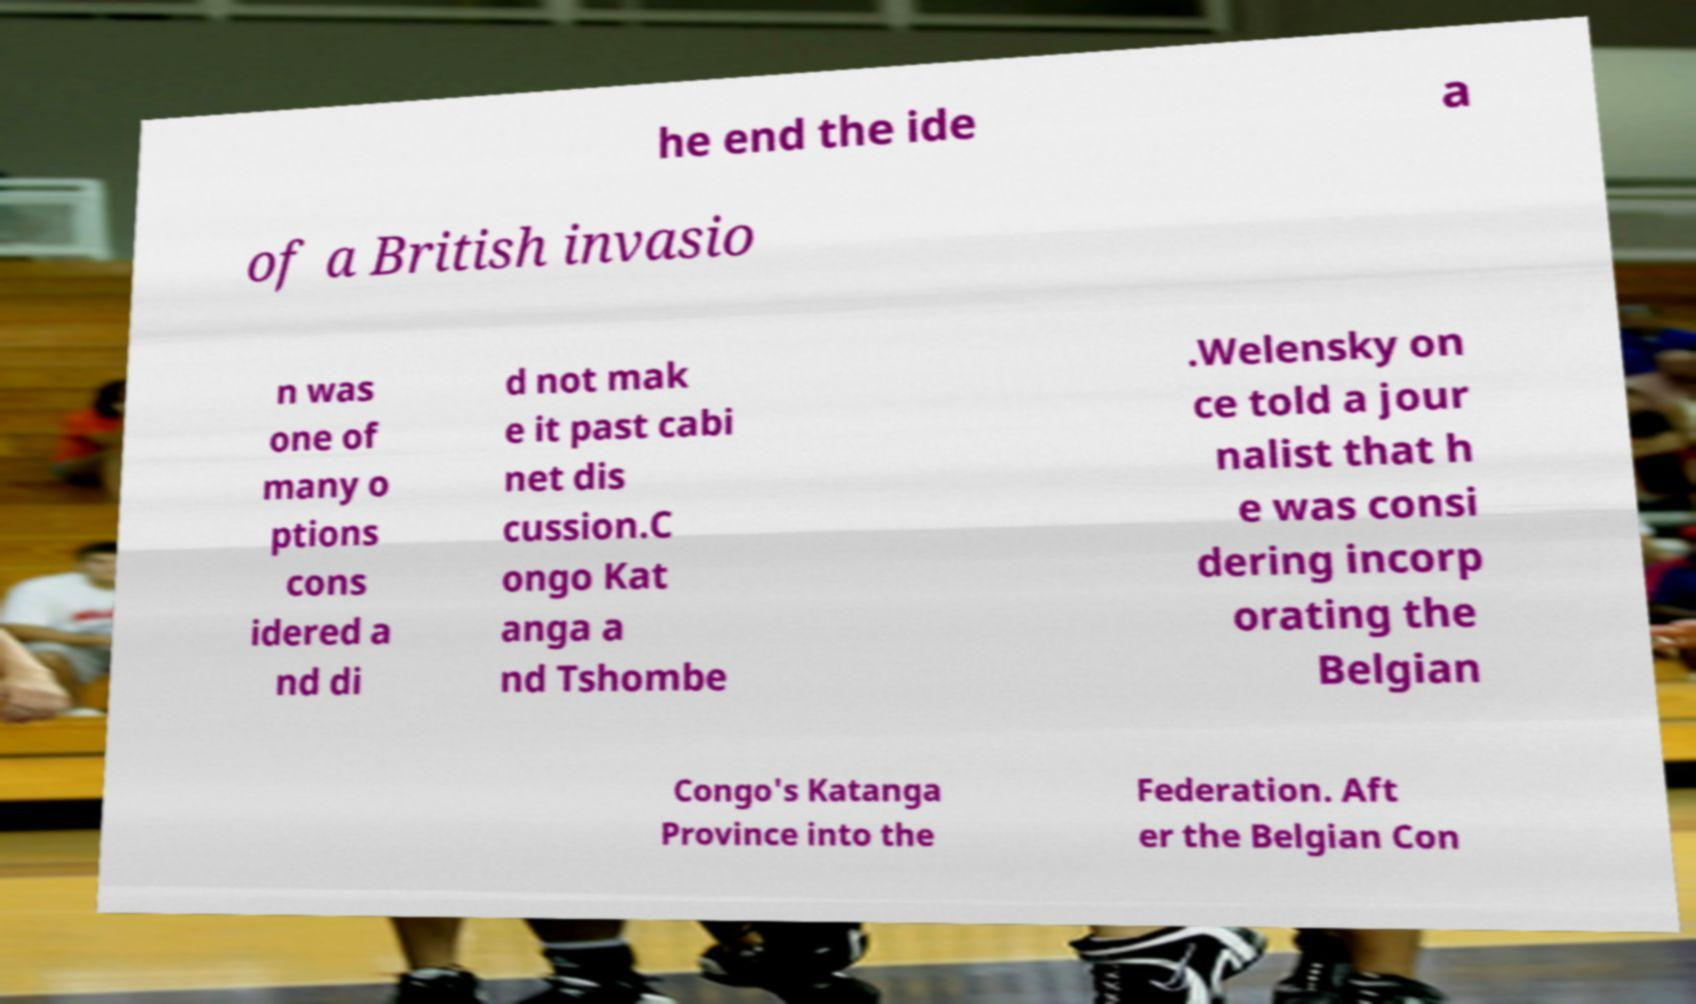There's text embedded in this image that I need extracted. Can you transcribe it verbatim? he end the ide a of a British invasio n was one of many o ptions cons idered a nd di d not mak e it past cabi net dis cussion.C ongo Kat anga a nd Tshombe .Welensky on ce told a jour nalist that h e was consi dering incorp orating the Belgian Congo's Katanga Province into the Federation. Aft er the Belgian Con 